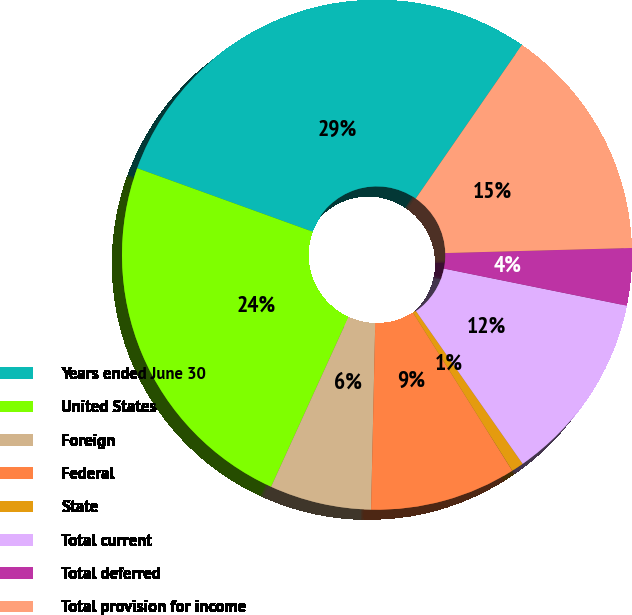Convert chart. <chart><loc_0><loc_0><loc_500><loc_500><pie_chart><fcel>Years ended June 30<fcel>United States<fcel>Foreign<fcel>Federal<fcel>State<fcel>Total current<fcel>Total deferred<fcel>Total provision for income<nl><fcel>29.1%<fcel>23.72%<fcel>6.45%<fcel>9.28%<fcel>0.78%<fcel>12.11%<fcel>3.62%<fcel>14.94%<nl></chart> 